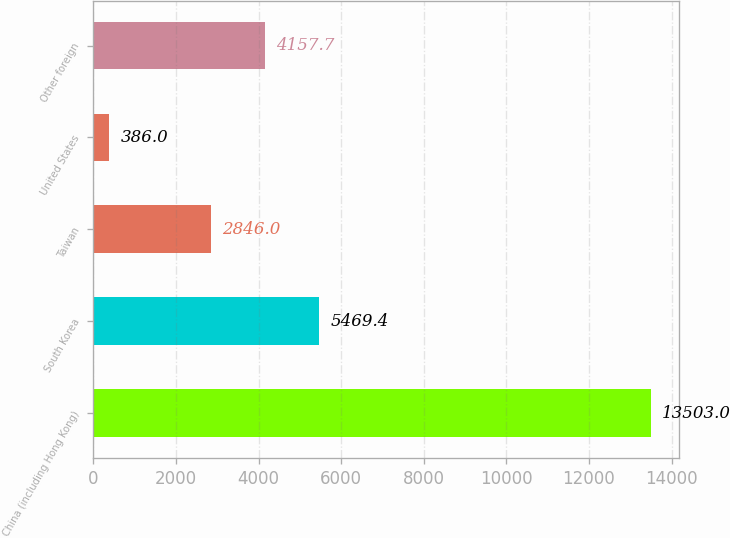Convert chart to OTSL. <chart><loc_0><loc_0><loc_500><loc_500><bar_chart><fcel>China (including Hong Kong)<fcel>South Korea<fcel>Taiwan<fcel>United States<fcel>Other foreign<nl><fcel>13503<fcel>5469.4<fcel>2846<fcel>386<fcel>4157.7<nl></chart> 